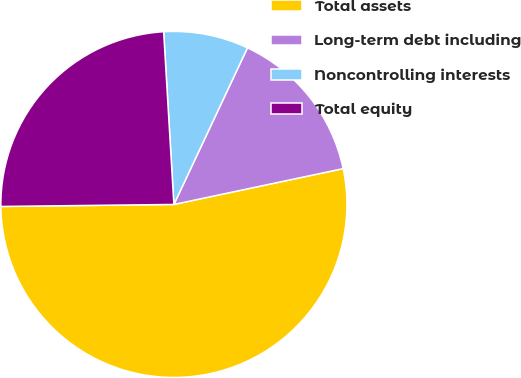<chart> <loc_0><loc_0><loc_500><loc_500><pie_chart><fcel>Total assets<fcel>Long-term debt including<fcel>Noncontrolling interests<fcel>Total equity<nl><fcel>53.13%<fcel>14.69%<fcel>7.93%<fcel>24.24%<nl></chart> 